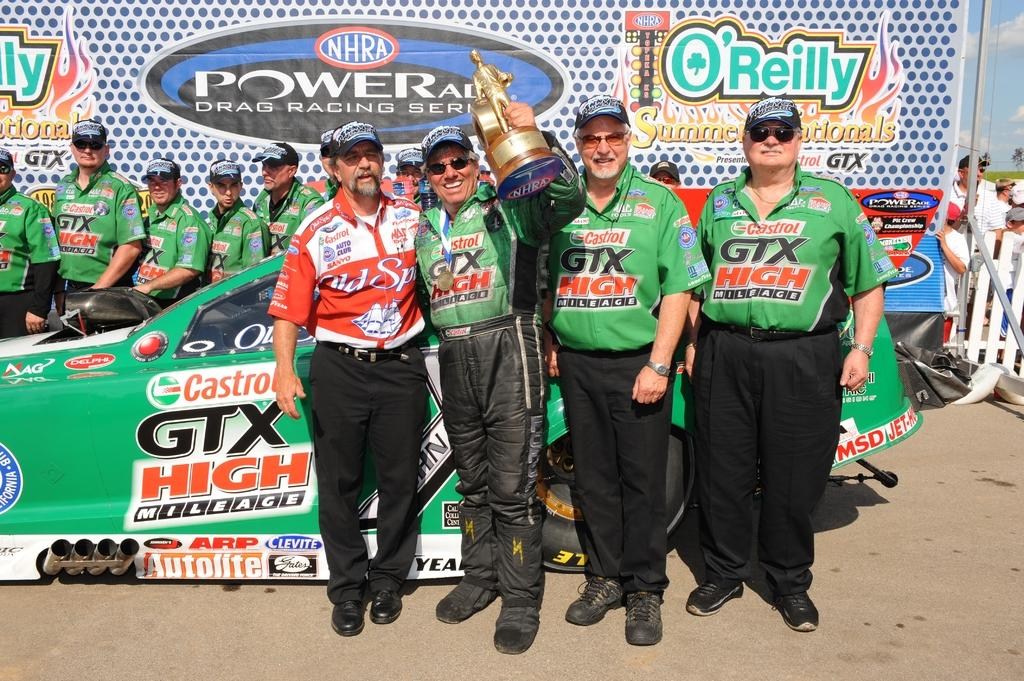<image>
Present a compact description of the photo's key features. A group of men are holding a golden trophy and standing by a race car that says Castrol on the side. 